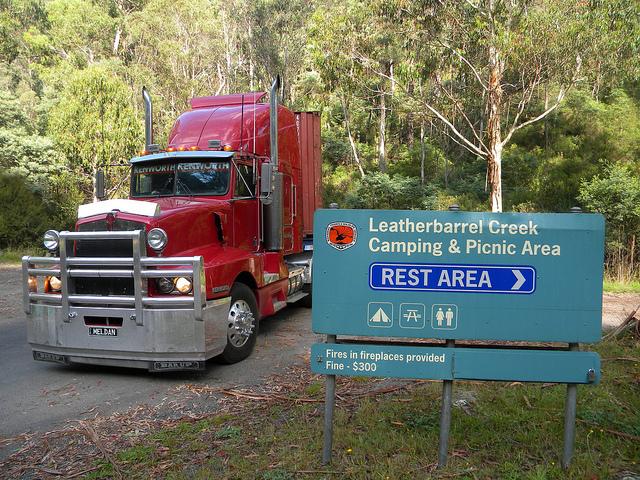What's the name of the creek?
Concise answer only. Leather barrel. What color is the sign?
Concise answer only. Blue. What color is the truck?
Keep it brief. Red. What model is the truck?
Be succinct. Kenworth. What color is the truck on the left?
Give a very brief answer. Red. 